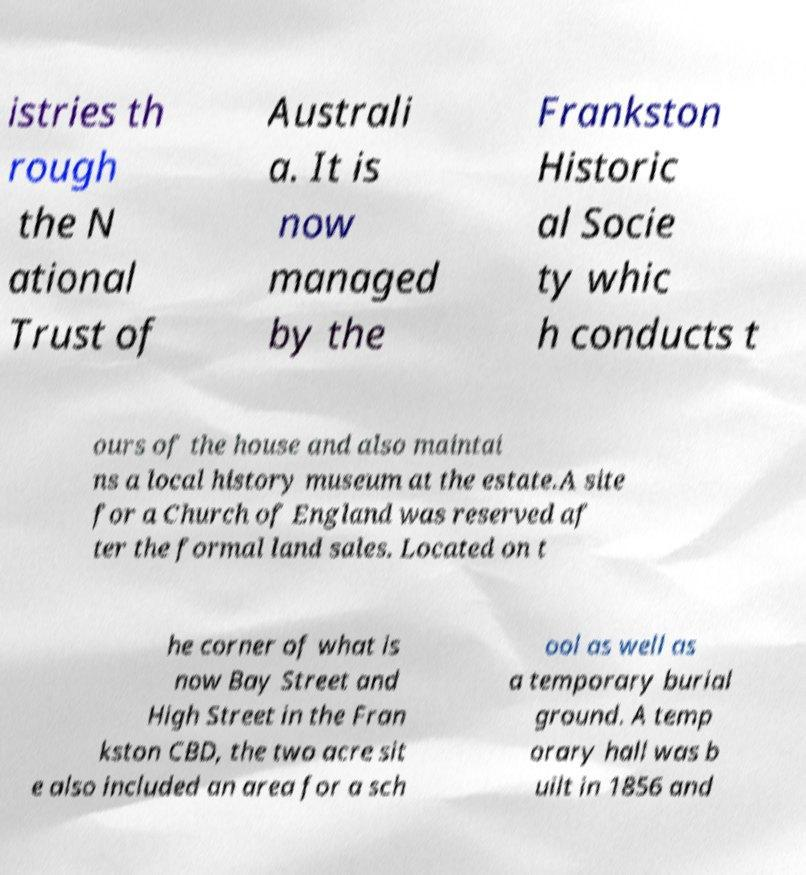There's text embedded in this image that I need extracted. Can you transcribe it verbatim? istries th rough the N ational Trust of Australi a. It is now managed by the Frankston Historic al Socie ty whic h conducts t ours of the house and also maintai ns a local history museum at the estate.A site for a Church of England was reserved af ter the formal land sales. Located on t he corner of what is now Bay Street and High Street in the Fran kston CBD, the two acre sit e also included an area for a sch ool as well as a temporary burial ground. A temp orary hall was b uilt in 1856 and 